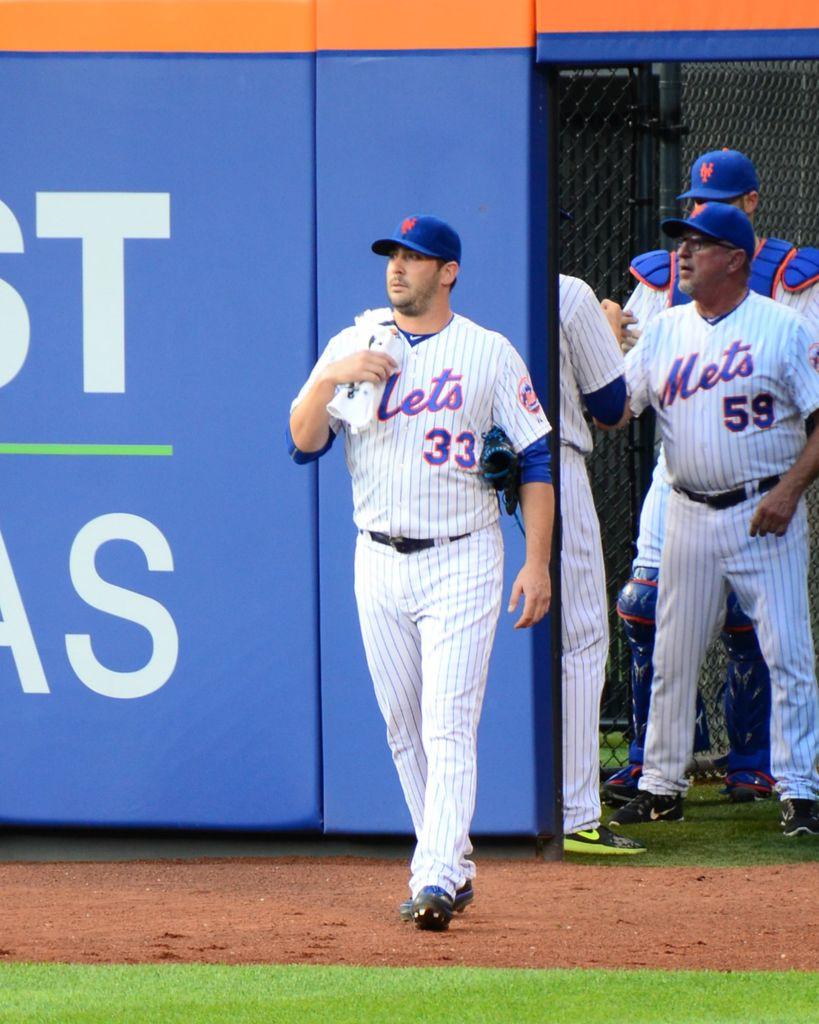What is the man in fronts jersey number?
Ensure brevity in your answer.  33. 